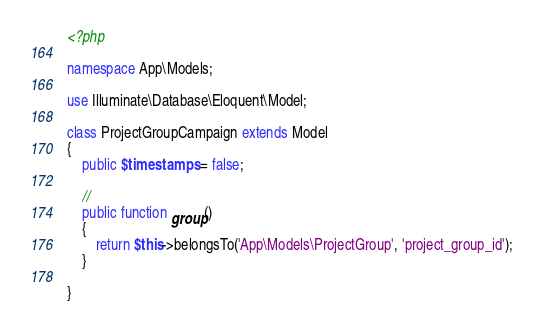Convert code to text. <code><loc_0><loc_0><loc_500><loc_500><_PHP_><?php

namespace App\Models;

use Illuminate\Database\Eloquent\Model;

class ProjectGroupCampaign extends Model
{
    public $timestamps = false;

    //
    public function group()
    {
        return $this->belongsTo('App\Models\ProjectGroup', 'project_group_id');
    }
    
}
</code> 